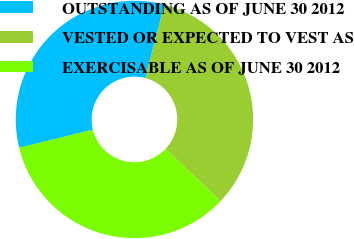Convert chart. <chart><loc_0><loc_0><loc_500><loc_500><pie_chart><fcel>OUTSTANDING AS OF JUNE 30 2012<fcel>VESTED OR EXPECTED TO VEST AS<fcel>EXERCISABLE AS OF JUNE 30 2012<nl><fcel>32.9%<fcel>33.02%<fcel>34.09%<nl></chart> 